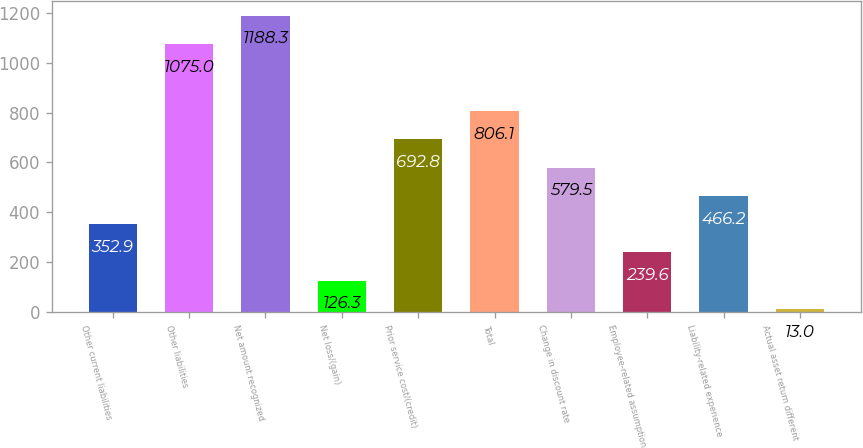Convert chart to OTSL. <chart><loc_0><loc_0><loc_500><loc_500><bar_chart><fcel>Other current liabilities<fcel>Other liabilities<fcel>Net amount recognized<fcel>Net loss/(gain)<fcel>Prior service cost/(credit)<fcel>Total<fcel>Change in discount rate<fcel>Employee-related assumption<fcel>Liability-related experience<fcel>Actual asset return different<nl><fcel>352.9<fcel>1075<fcel>1188.3<fcel>126.3<fcel>692.8<fcel>806.1<fcel>579.5<fcel>239.6<fcel>466.2<fcel>13<nl></chart> 